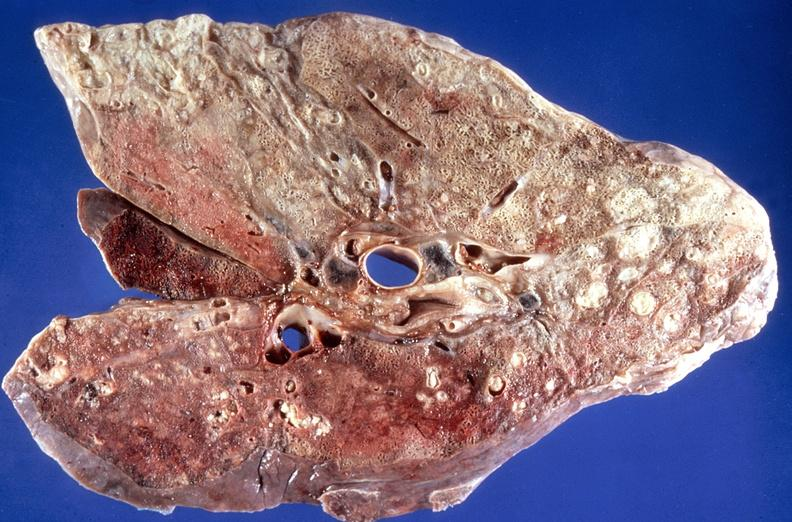s respiratory present?
Answer the question using a single word or phrase. Yes 